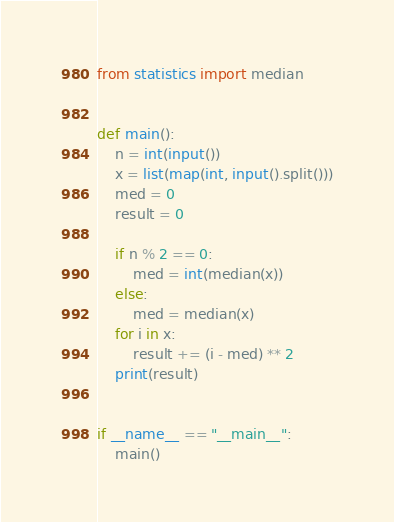Convert code to text. <code><loc_0><loc_0><loc_500><loc_500><_Python_>from statistics import median


def main():
    n = int(input())
    x = list(map(int, input().split()))
    med = 0
    result = 0

    if n % 2 == 0:
        med = int(median(x))
    else:
        med = median(x)
    for i in x:
        result += (i - med) ** 2
    print(result)


if __name__ == "__main__":
    main()
</code> 